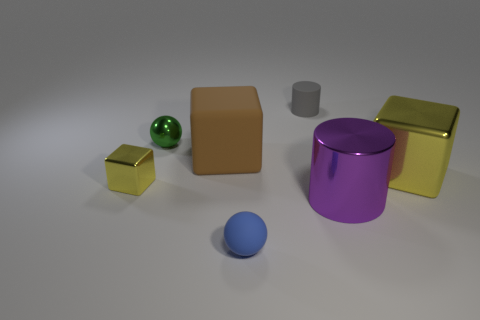There is a yellow block on the left side of the purple object; is there a rubber thing that is to the left of it?
Offer a terse response. No. The green thing has what size?
Your response must be concise. Small. There is a thing that is to the left of the tiny blue matte object and behind the brown thing; what shape is it?
Make the answer very short. Sphere. What number of gray objects are either spheres or small matte objects?
Your answer should be very brief. 1. There is a yellow thing behind the small metallic cube; is it the same size as the metal block that is left of the large purple cylinder?
Give a very brief answer. No. How many objects are rubber spheres or small green rubber things?
Give a very brief answer. 1. Is there a tiny red metallic object that has the same shape as the tiny gray thing?
Keep it short and to the point. No. Is the number of brown blocks less than the number of matte things?
Provide a short and direct response. Yes. Is the purple shiny thing the same shape as the green thing?
Provide a succinct answer. No. What number of things are either blue balls or blocks on the right side of the rubber cube?
Provide a short and direct response. 2. 